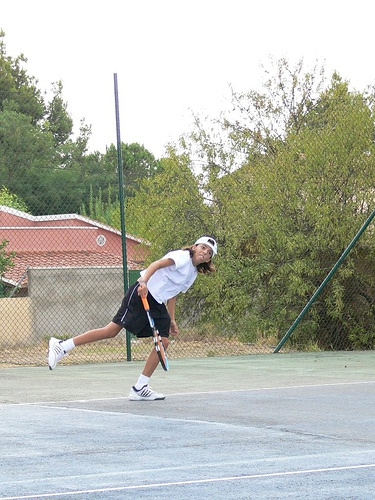Describe the objects in this image and their specific colors. I can see people in white, lavender, black, and gray tones and tennis racket in white, black, lightgray, gray, and darkgray tones in this image. 